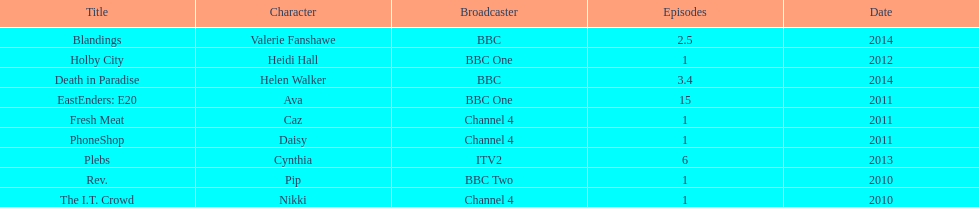How many titles have at least 5 episodes? 2. 